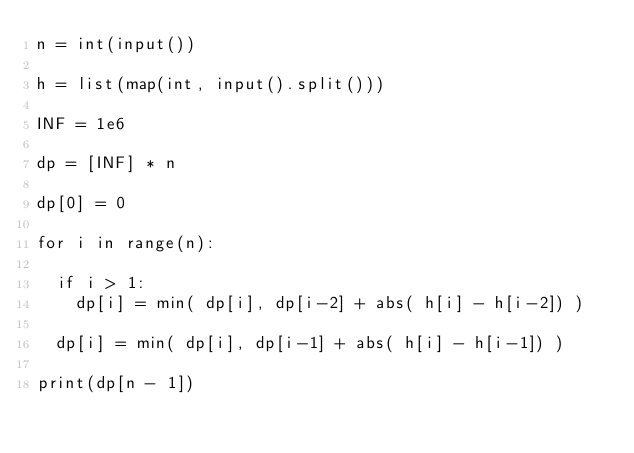Convert code to text. <code><loc_0><loc_0><loc_500><loc_500><_Python_>n = int(input())

h = list(map(int, input().split()))

INF = 1e6

dp = [INF] * n 

dp[0] = 0

for i in range(n):

	if i > 1:
		dp[i] = min( dp[i], dp[i-2] + abs( h[i] - h[i-2]) )

	dp[i] = min( dp[i], dp[i-1] + abs( h[i] - h[i-1]) )

print(dp[n - 1])</code> 